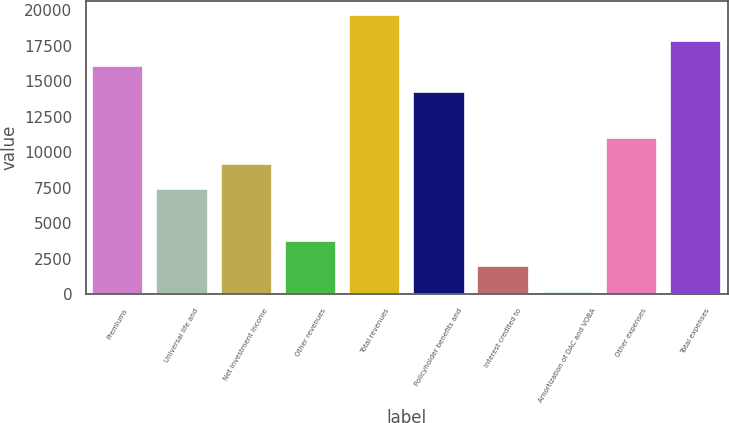Convert chart. <chart><loc_0><loc_0><loc_500><loc_500><bar_chart><fcel>Premiums<fcel>Universal life and<fcel>Net investment income<fcel>Other revenues<fcel>Total revenues<fcel>Policyholder benefits and<fcel>Interest credited to<fcel>Amortization of DAC and VOBA<fcel>Other expenses<fcel>Total expenses<nl><fcel>16034.2<fcel>7368.8<fcel>9176<fcel>3754.4<fcel>19648.6<fcel>14227<fcel>1947.2<fcel>140<fcel>10983.2<fcel>17841.4<nl></chart> 